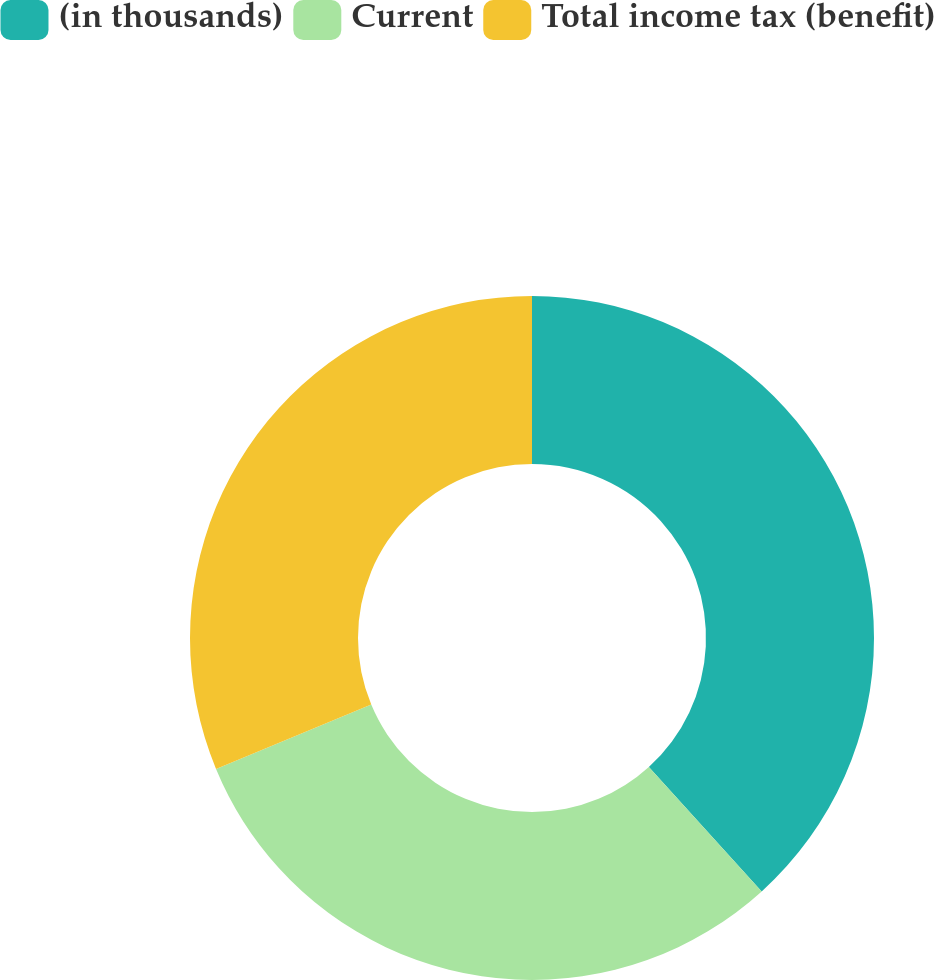Convert chart. <chart><loc_0><loc_0><loc_500><loc_500><pie_chart><fcel>(in thousands)<fcel>Current<fcel>Total income tax (benefit)<nl><fcel>38.28%<fcel>30.47%<fcel>31.25%<nl></chart> 